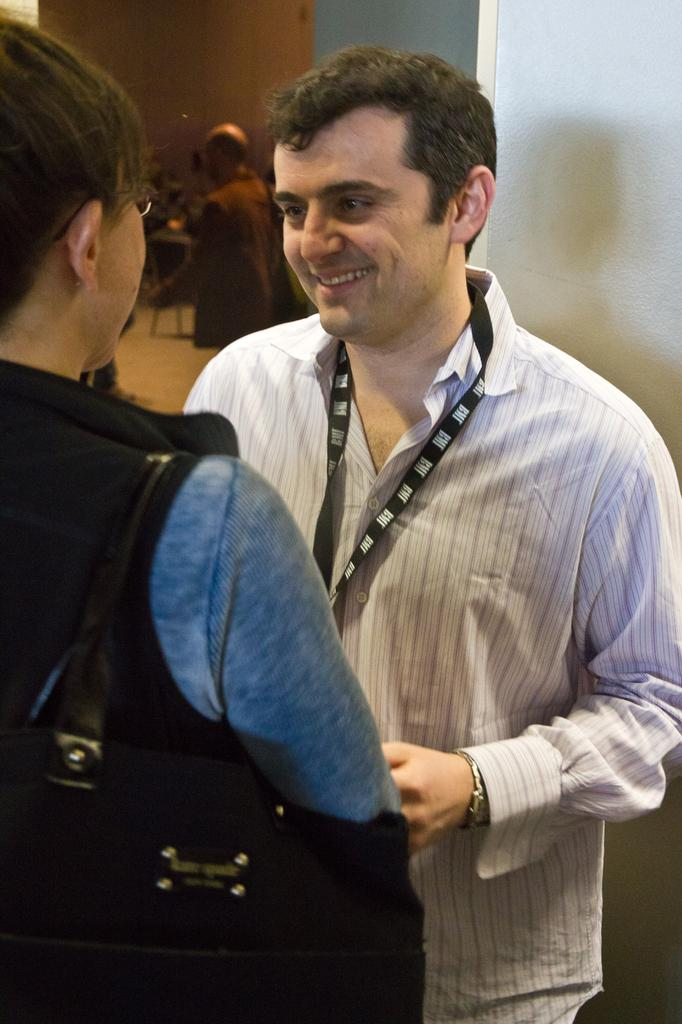Who are the two people standing in the center of the image? There is a man and a woman standing in the center of the image. What is the woman wearing that is visible in the image? The woman is wearing a bag. Can you describe the person visible on the backside of the image? There is a person visible on the backside of the image, but no specific details are provided. What type of structure can be seen on the backside of the image? There is a wall visible on the backside of the image. What type of breakfast is being served in the image? There is no mention of breakfast in the image. 